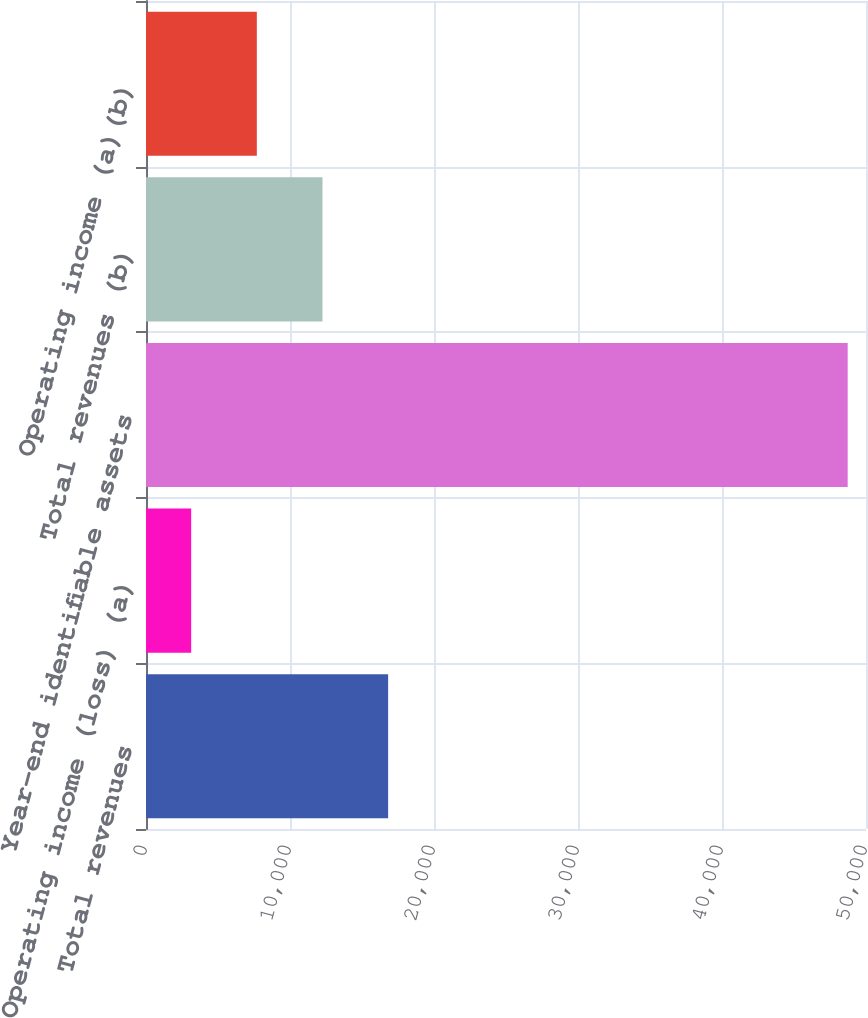<chart> <loc_0><loc_0><loc_500><loc_500><bar_chart><fcel>Total revenues<fcel>Operating income (loss) (a)<fcel>Year-end identifiable assets<fcel>Total revenues (b)<fcel>Operating income (a)(b)<nl><fcel>16814.3<fcel>3137<fcel>48728<fcel>12255.2<fcel>7696.1<nl></chart> 